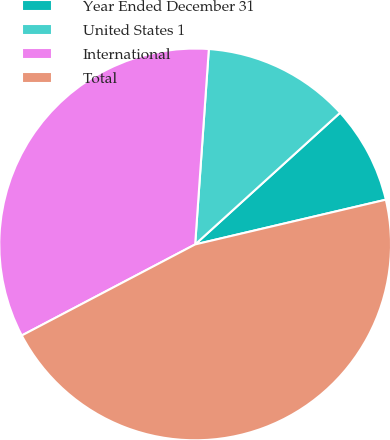<chart> <loc_0><loc_0><loc_500><loc_500><pie_chart><fcel>Year Ended December 31<fcel>United States 1<fcel>International<fcel>Total<nl><fcel>8.07%<fcel>12.15%<fcel>33.81%<fcel>45.97%<nl></chart> 